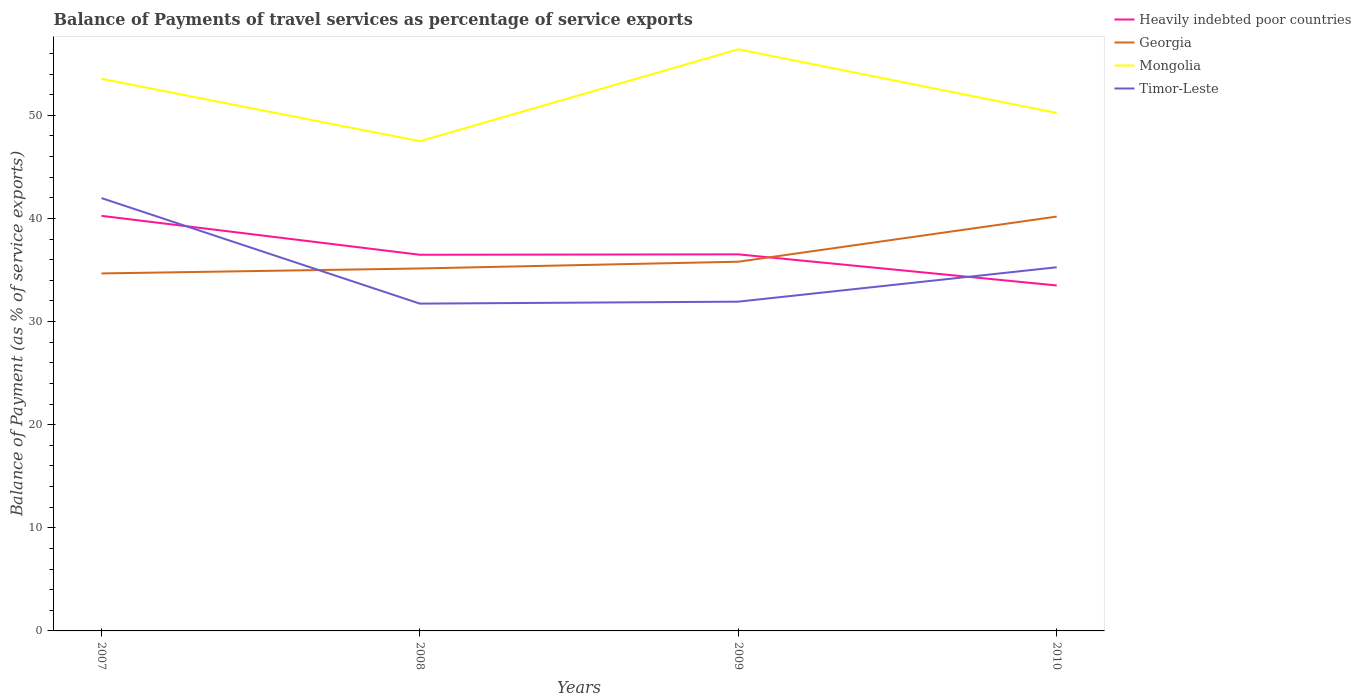How many different coloured lines are there?
Your answer should be very brief. 4. Across all years, what is the maximum balance of payments of travel services in Georgia?
Offer a terse response. 34.66. What is the total balance of payments of travel services in Timor-Leste in the graph?
Offer a terse response. -3.52. What is the difference between the highest and the second highest balance of payments of travel services in Timor-Leste?
Offer a terse response. 10.23. Is the balance of payments of travel services in Timor-Leste strictly greater than the balance of payments of travel services in Mongolia over the years?
Give a very brief answer. Yes. What is the difference between two consecutive major ticks on the Y-axis?
Your answer should be very brief. 10. How are the legend labels stacked?
Provide a short and direct response. Vertical. What is the title of the graph?
Your answer should be compact. Balance of Payments of travel services as percentage of service exports. Does "Lithuania" appear as one of the legend labels in the graph?
Provide a succinct answer. No. What is the label or title of the Y-axis?
Provide a short and direct response. Balance of Payment (as % of service exports). What is the Balance of Payment (as % of service exports) in Heavily indebted poor countries in 2007?
Provide a succinct answer. 40.25. What is the Balance of Payment (as % of service exports) of Georgia in 2007?
Keep it short and to the point. 34.66. What is the Balance of Payment (as % of service exports) of Mongolia in 2007?
Keep it short and to the point. 53.54. What is the Balance of Payment (as % of service exports) of Timor-Leste in 2007?
Provide a short and direct response. 41.97. What is the Balance of Payment (as % of service exports) of Heavily indebted poor countries in 2008?
Provide a succinct answer. 36.48. What is the Balance of Payment (as % of service exports) of Georgia in 2008?
Your answer should be very brief. 35.15. What is the Balance of Payment (as % of service exports) of Mongolia in 2008?
Offer a very short reply. 47.49. What is the Balance of Payment (as % of service exports) of Timor-Leste in 2008?
Ensure brevity in your answer.  31.74. What is the Balance of Payment (as % of service exports) in Heavily indebted poor countries in 2009?
Give a very brief answer. 36.51. What is the Balance of Payment (as % of service exports) of Georgia in 2009?
Your response must be concise. 35.8. What is the Balance of Payment (as % of service exports) in Mongolia in 2009?
Ensure brevity in your answer.  56.4. What is the Balance of Payment (as % of service exports) of Timor-Leste in 2009?
Provide a short and direct response. 31.93. What is the Balance of Payment (as % of service exports) of Heavily indebted poor countries in 2010?
Ensure brevity in your answer.  33.5. What is the Balance of Payment (as % of service exports) in Georgia in 2010?
Provide a succinct answer. 40.18. What is the Balance of Payment (as % of service exports) of Mongolia in 2010?
Your answer should be compact. 50.23. What is the Balance of Payment (as % of service exports) in Timor-Leste in 2010?
Give a very brief answer. 35.26. Across all years, what is the maximum Balance of Payment (as % of service exports) in Heavily indebted poor countries?
Your answer should be compact. 40.25. Across all years, what is the maximum Balance of Payment (as % of service exports) in Georgia?
Keep it short and to the point. 40.18. Across all years, what is the maximum Balance of Payment (as % of service exports) in Mongolia?
Offer a terse response. 56.4. Across all years, what is the maximum Balance of Payment (as % of service exports) in Timor-Leste?
Give a very brief answer. 41.97. Across all years, what is the minimum Balance of Payment (as % of service exports) in Heavily indebted poor countries?
Your answer should be very brief. 33.5. Across all years, what is the minimum Balance of Payment (as % of service exports) of Georgia?
Offer a very short reply. 34.66. Across all years, what is the minimum Balance of Payment (as % of service exports) in Mongolia?
Your response must be concise. 47.49. Across all years, what is the minimum Balance of Payment (as % of service exports) of Timor-Leste?
Your answer should be very brief. 31.74. What is the total Balance of Payment (as % of service exports) of Heavily indebted poor countries in the graph?
Provide a short and direct response. 146.74. What is the total Balance of Payment (as % of service exports) in Georgia in the graph?
Give a very brief answer. 145.79. What is the total Balance of Payment (as % of service exports) of Mongolia in the graph?
Give a very brief answer. 207.65. What is the total Balance of Payment (as % of service exports) of Timor-Leste in the graph?
Make the answer very short. 140.9. What is the difference between the Balance of Payment (as % of service exports) of Heavily indebted poor countries in 2007 and that in 2008?
Your answer should be compact. 3.77. What is the difference between the Balance of Payment (as % of service exports) of Georgia in 2007 and that in 2008?
Keep it short and to the point. -0.48. What is the difference between the Balance of Payment (as % of service exports) in Mongolia in 2007 and that in 2008?
Keep it short and to the point. 6.05. What is the difference between the Balance of Payment (as % of service exports) of Timor-Leste in 2007 and that in 2008?
Make the answer very short. 10.23. What is the difference between the Balance of Payment (as % of service exports) of Heavily indebted poor countries in 2007 and that in 2009?
Your answer should be compact. 3.73. What is the difference between the Balance of Payment (as % of service exports) in Georgia in 2007 and that in 2009?
Offer a very short reply. -1.14. What is the difference between the Balance of Payment (as % of service exports) in Mongolia in 2007 and that in 2009?
Provide a short and direct response. -2.86. What is the difference between the Balance of Payment (as % of service exports) of Timor-Leste in 2007 and that in 2009?
Your answer should be very brief. 10.04. What is the difference between the Balance of Payment (as % of service exports) of Heavily indebted poor countries in 2007 and that in 2010?
Provide a short and direct response. 6.75. What is the difference between the Balance of Payment (as % of service exports) in Georgia in 2007 and that in 2010?
Provide a short and direct response. -5.51. What is the difference between the Balance of Payment (as % of service exports) of Mongolia in 2007 and that in 2010?
Your response must be concise. 3.31. What is the difference between the Balance of Payment (as % of service exports) in Timor-Leste in 2007 and that in 2010?
Your answer should be very brief. 6.71. What is the difference between the Balance of Payment (as % of service exports) in Heavily indebted poor countries in 2008 and that in 2009?
Make the answer very short. -0.04. What is the difference between the Balance of Payment (as % of service exports) in Georgia in 2008 and that in 2009?
Offer a terse response. -0.65. What is the difference between the Balance of Payment (as % of service exports) of Mongolia in 2008 and that in 2009?
Ensure brevity in your answer.  -8.91. What is the difference between the Balance of Payment (as % of service exports) of Timor-Leste in 2008 and that in 2009?
Provide a succinct answer. -0.19. What is the difference between the Balance of Payment (as % of service exports) of Heavily indebted poor countries in 2008 and that in 2010?
Your answer should be very brief. 2.98. What is the difference between the Balance of Payment (as % of service exports) of Georgia in 2008 and that in 2010?
Offer a very short reply. -5.03. What is the difference between the Balance of Payment (as % of service exports) in Mongolia in 2008 and that in 2010?
Keep it short and to the point. -2.74. What is the difference between the Balance of Payment (as % of service exports) in Timor-Leste in 2008 and that in 2010?
Offer a terse response. -3.52. What is the difference between the Balance of Payment (as % of service exports) in Heavily indebted poor countries in 2009 and that in 2010?
Provide a succinct answer. 3.01. What is the difference between the Balance of Payment (as % of service exports) in Georgia in 2009 and that in 2010?
Your answer should be compact. -4.38. What is the difference between the Balance of Payment (as % of service exports) in Mongolia in 2009 and that in 2010?
Make the answer very short. 6.17. What is the difference between the Balance of Payment (as % of service exports) in Timor-Leste in 2009 and that in 2010?
Your response must be concise. -3.33. What is the difference between the Balance of Payment (as % of service exports) in Heavily indebted poor countries in 2007 and the Balance of Payment (as % of service exports) in Georgia in 2008?
Keep it short and to the point. 5.1. What is the difference between the Balance of Payment (as % of service exports) of Heavily indebted poor countries in 2007 and the Balance of Payment (as % of service exports) of Mongolia in 2008?
Your answer should be very brief. -7.24. What is the difference between the Balance of Payment (as % of service exports) of Heavily indebted poor countries in 2007 and the Balance of Payment (as % of service exports) of Timor-Leste in 2008?
Make the answer very short. 8.51. What is the difference between the Balance of Payment (as % of service exports) in Georgia in 2007 and the Balance of Payment (as % of service exports) in Mongolia in 2008?
Your answer should be very brief. -12.82. What is the difference between the Balance of Payment (as % of service exports) in Georgia in 2007 and the Balance of Payment (as % of service exports) in Timor-Leste in 2008?
Give a very brief answer. 2.93. What is the difference between the Balance of Payment (as % of service exports) in Mongolia in 2007 and the Balance of Payment (as % of service exports) in Timor-Leste in 2008?
Offer a very short reply. 21.8. What is the difference between the Balance of Payment (as % of service exports) of Heavily indebted poor countries in 2007 and the Balance of Payment (as % of service exports) of Georgia in 2009?
Provide a succinct answer. 4.45. What is the difference between the Balance of Payment (as % of service exports) in Heavily indebted poor countries in 2007 and the Balance of Payment (as % of service exports) in Mongolia in 2009?
Your answer should be very brief. -16.15. What is the difference between the Balance of Payment (as % of service exports) in Heavily indebted poor countries in 2007 and the Balance of Payment (as % of service exports) in Timor-Leste in 2009?
Ensure brevity in your answer.  8.32. What is the difference between the Balance of Payment (as % of service exports) in Georgia in 2007 and the Balance of Payment (as % of service exports) in Mongolia in 2009?
Offer a very short reply. -21.73. What is the difference between the Balance of Payment (as % of service exports) in Georgia in 2007 and the Balance of Payment (as % of service exports) in Timor-Leste in 2009?
Your answer should be compact. 2.74. What is the difference between the Balance of Payment (as % of service exports) of Mongolia in 2007 and the Balance of Payment (as % of service exports) of Timor-Leste in 2009?
Offer a terse response. 21.61. What is the difference between the Balance of Payment (as % of service exports) in Heavily indebted poor countries in 2007 and the Balance of Payment (as % of service exports) in Georgia in 2010?
Offer a terse response. 0.07. What is the difference between the Balance of Payment (as % of service exports) in Heavily indebted poor countries in 2007 and the Balance of Payment (as % of service exports) in Mongolia in 2010?
Give a very brief answer. -9.98. What is the difference between the Balance of Payment (as % of service exports) in Heavily indebted poor countries in 2007 and the Balance of Payment (as % of service exports) in Timor-Leste in 2010?
Keep it short and to the point. 4.99. What is the difference between the Balance of Payment (as % of service exports) in Georgia in 2007 and the Balance of Payment (as % of service exports) in Mongolia in 2010?
Your answer should be very brief. -15.56. What is the difference between the Balance of Payment (as % of service exports) of Georgia in 2007 and the Balance of Payment (as % of service exports) of Timor-Leste in 2010?
Keep it short and to the point. -0.6. What is the difference between the Balance of Payment (as % of service exports) in Mongolia in 2007 and the Balance of Payment (as % of service exports) in Timor-Leste in 2010?
Provide a short and direct response. 18.28. What is the difference between the Balance of Payment (as % of service exports) of Heavily indebted poor countries in 2008 and the Balance of Payment (as % of service exports) of Georgia in 2009?
Your response must be concise. 0.68. What is the difference between the Balance of Payment (as % of service exports) of Heavily indebted poor countries in 2008 and the Balance of Payment (as % of service exports) of Mongolia in 2009?
Offer a very short reply. -19.92. What is the difference between the Balance of Payment (as % of service exports) in Heavily indebted poor countries in 2008 and the Balance of Payment (as % of service exports) in Timor-Leste in 2009?
Give a very brief answer. 4.55. What is the difference between the Balance of Payment (as % of service exports) of Georgia in 2008 and the Balance of Payment (as % of service exports) of Mongolia in 2009?
Your answer should be very brief. -21.25. What is the difference between the Balance of Payment (as % of service exports) of Georgia in 2008 and the Balance of Payment (as % of service exports) of Timor-Leste in 2009?
Provide a short and direct response. 3.22. What is the difference between the Balance of Payment (as % of service exports) of Mongolia in 2008 and the Balance of Payment (as % of service exports) of Timor-Leste in 2009?
Give a very brief answer. 15.56. What is the difference between the Balance of Payment (as % of service exports) of Heavily indebted poor countries in 2008 and the Balance of Payment (as % of service exports) of Georgia in 2010?
Offer a very short reply. -3.7. What is the difference between the Balance of Payment (as % of service exports) in Heavily indebted poor countries in 2008 and the Balance of Payment (as % of service exports) in Mongolia in 2010?
Your answer should be very brief. -13.75. What is the difference between the Balance of Payment (as % of service exports) of Heavily indebted poor countries in 2008 and the Balance of Payment (as % of service exports) of Timor-Leste in 2010?
Keep it short and to the point. 1.21. What is the difference between the Balance of Payment (as % of service exports) of Georgia in 2008 and the Balance of Payment (as % of service exports) of Mongolia in 2010?
Your answer should be compact. -15.08. What is the difference between the Balance of Payment (as % of service exports) in Georgia in 2008 and the Balance of Payment (as % of service exports) in Timor-Leste in 2010?
Your response must be concise. -0.12. What is the difference between the Balance of Payment (as % of service exports) of Mongolia in 2008 and the Balance of Payment (as % of service exports) of Timor-Leste in 2010?
Give a very brief answer. 12.23. What is the difference between the Balance of Payment (as % of service exports) of Heavily indebted poor countries in 2009 and the Balance of Payment (as % of service exports) of Georgia in 2010?
Your answer should be compact. -3.66. What is the difference between the Balance of Payment (as % of service exports) of Heavily indebted poor countries in 2009 and the Balance of Payment (as % of service exports) of Mongolia in 2010?
Offer a terse response. -13.71. What is the difference between the Balance of Payment (as % of service exports) in Heavily indebted poor countries in 2009 and the Balance of Payment (as % of service exports) in Timor-Leste in 2010?
Give a very brief answer. 1.25. What is the difference between the Balance of Payment (as % of service exports) in Georgia in 2009 and the Balance of Payment (as % of service exports) in Mongolia in 2010?
Your answer should be compact. -14.43. What is the difference between the Balance of Payment (as % of service exports) of Georgia in 2009 and the Balance of Payment (as % of service exports) of Timor-Leste in 2010?
Offer a very short reply. 0.54. What is the difference between the Balance of Payment (as % of service exports) in Mongolia in 2009 and the Balance of Payment (as % of service exports) in Timor-Leste in 2010?
Provide a succinct answer. 21.14. What is the average Balance of Payment (as % of service exports) in Heavily indebted poor countries per year?
Your answer should be very brief. 36.68. What is the average Balance of Payment (as % of service exports) in Georgia per year?
Your answer should be compact. 36.45. What is the average Balance of Payment (as % of service exports) of Mongolia per year?
Provide a succinct answer. 51.91. What is the average Balance of Payment (as % of service exports) of Timor-Leste per year?
Offer a very short reply. 35.22. In the year 2007, what is the difference between the Balance of Payment (as % of service exports) of Heavily indebted poor countries and Balance of Payment (as % of service exports) of Georgia?
Make the answer very short. 5.59. In the year 2007, what is the difference between the Balance of Payment (as % of service exports) in Heavily indebted poor countries and Balance of Payment (as % of service exports) in Mongolia?
Ensure brevity in your answer.  -13.29. In the year 2007, what is the difference between the Balance of Payment (as % of service exports) of Heavily indebted poor countries and Balance of Payment (as % of service exports) of Timor-Leste?
Provide a short and direct response. -1.72. In the year 2007, what is the difference between the Balance of Payment (as % of service exports) of Georgia and Balance of Payment (as % of service exports) of Mongolia?
Give a very brief answer. -18.87. In the year 2007, what is the difference between the Balance of Payment (as % of service exports) in Georgia and Balance of Payment (as % of service exports) in Timor-Leste?
Give a very brief answer. -7.31. In the year 2007, what is the difference between the Balance of Payment (as % of service exports) of Mongolia and Balance of Payment (as % of service exports) of Timor-Leste?
Offer a very short reply. 11.57. In the year 2008, what is the difference between the Balance of Payment (as % of service exports) in Heavily indebted poor countries and Balance of Payment (as % of service exports) in Georgia?
Your answer should be very brief. 1.33. In the year 2008, what is the difference between the Balance of Payment (as % of service exports) of Heavily indebted poor countries and Balance of Payment (as % of service exports) of Mongolia?
Your response must be concise. -11.01. In the year 2008, what is the difference between the Balance of Payment (as % of service exports) in Heavily indebted poor countries and Balance of Payment (as % of service exports) in Timor-Leste?
Your answer should be compact. 4.74. In the year 2008, what is the difference between the Balance of Payment (as % of service exports) of Georgia and Balance of Payment (as % of service exports) of Mongolia?
Your answer should be very brief. -12.34. In the year 2008, what is the difference between the Balance of Payment (as % of service exports) in Georgia and Balance of Payment (as % of service exports) in Timor-Leste?
Your answer should be compact. 3.41. In the year 2008, what is the difference between the Balance of Payment (as % of service exports) in Mongolia and Balance of Payment (as % of service exports) in Timor-Leste?
Your response must be concise. 15.75. In the year 2009, what is the difference between the Balance of Payment (as % of service exports) in Heavily indebted poor countries and Balance of Payment (as % of service exports) in Georgia?
Keep it short and to the point. 0.71. In the year 2009, what is the difference between the Balance of Payment (as % of service exports) in Heavily indebted poor countries and Balance of Payment (as % of service exports) in Mongolia?
Make the answer very short. -19.88. In the year 2009, what is the difference between the Balance of Payment (as % of service exports) in Heavily indebted poor countries and Balance of Payment (as % of service exports) in Timor-Leste?
Offer a terse response. 4.59. In the year 2009, what is the difference between the Balance of Payment (as % of service exports) in Georgia and Balance of Payment (as % of service exports) in Mongolia?
Ensure brevity in your answer.  -20.6. In the year 2009, what is the difference between the Balance of Payment (as % of service exports) of Georgia and Balance of Payment (as % of service exports) of Timor-Leste?
Your answer should be very brief. 3.87. In the year 2009, what is the difference between the Balance of Payment (as % of service exports) of Mongolia and Balance of Payment (as % of service exports) of Timor-Leste?
Your answer should be compact. 24.47. In the year 2010, what is the difference between the Balance of Payment (as % of service exports) of Heavily indebted poor countries and Balance of Payment (as % of service exports) of Georgia?
Make the answer very short. -6.68. In the year 2010, what is the difference between the Balance of Payment (as % of service exports) in Heavily indebted poor countries and Balance of Payment (as % of service exports) in Mongolia?
Offer a terse response. -16.73. In the year 2010, what is the difference between the Balance of Payment (as % of service exports) of Heavily indebted poor countries and Balance of Payment (as % of service exports) of Timor-Leste?
Make the answer very short. -1.76. In the year 2010, what is the difference between the Balance of Payment (as % of service exports) in Georgia and Balance of Payment (as % of service exports) in Mongolia?
Provide a short and direct response. -10.05. In the year 2010, what is the difference between the Balance of Payment (as % of service exports) of Georgia and Balance of Payment (as % of service exports) of Timor-Leste?
Provide a short and direct response. 4.92. In the year 2010, what is the difference between the Balance of Payment (as % of service exports) of Mongolia and Balance of Payment (as % of service exports) of Timor-Leste?
Provide a short and direct response. 14.97. What is the ratio of the Balance of Payment (as % of service exports) of Heavily indebted poor countries in 2007 to that in 2008?
Make the answer very short. 1.1. What is the ratio of the Balance of Payment (as % of service exports) in Georgia in 2007 to that in 2008?
Give a very brief answer. 0.99. What is the ratio of the Balance of Payment (as % of service exports) of Mongolia in 2007 to that in 2008?
Provide a short and direct response. 1.13. What is the ratio of the Balance of Payment (as % of service exports) of Timor-Leste in 2007 to that in 2008?
Your answer should be compact. 1.32. What is the ratio of the Balance of Payment (as % of service exports) of Heavily indebted poor countries in 2007 to that in 2009?
Provide a short and direct response. 1.1. What is the ratio of the Balance of Payment (as % of service exports) in Georgia in 2007 to that in 2009?
Offer a terse response. 0.97. What is the ratio of the Balance of Payment (as % of service exports) in Mongolia in 2007 to that in 2009?
Your answer should be very brief. 0.95. What is the ratio of the Balance of Payment (as % of service exports) in Timor-Leste in 2007 to that in 2009?
Ensure brevity in your answer.  1.31. What is the ratio of the Balance of Payment (as % of service exports) in Heavily indebted poor countries in 2007 to that in 2010?
Your response must be concise. 1.2. What is the ratio of the Balance of Payment (as % of service exports) in Georgia in 2007 to that in 2010?
Your answer should be very brief. 0.86. What is the ratio of the Balance of Payment (as % of service exports) of Mongolia in 2007 to that in 2010?
Your answer should be compact. 1.07. What is the ratio of the Balance of Payment (as % of service exports) in Timor-Leste in 2007 to that in 2010?
Keep it short and to the point. 1.19. What is the ratio of the Balance of Payment (as % of service exports) in Georgia in 2008 to that in 2009?
Offer a terse response. 0.98. What is the ratio of the Balance of Payment (as % of service exports) of Mongolia in 2008 to that in 2009?
Provide a succinct answer. 0.84. What is the ratio of the Balance of Payment (as % of service exports) in Timor-Leste in 2008 to that in 2009?
Provide a succinct answer. 0.99. What is the ratio of the Balance of Payment (as % of service exports) of Heavily indebted poor countries in 2008 to that in 2010?
Offer a terse response. 1.09. What is the ratio of the Balance of Payment (as % of service exports) in Georgia in 2008 to that in 2010?
Provide a short and direct response. 0.87. What is the ratio of the Balance of Payment (as % of service exports) of Mongolia in 2008 to that in 2010?
Ensure brevity in your answer.  0.95. What is the ratio of the Balance of Payment (as % of service exports) in Timor-Leste in 2008 to that in 2010?
Your answer should be very brief. 0.9. What is the ratio of the Balance of Payment (as % of service exports) of Heavily indebted poor countries in 2009 to that in 2010?
Offer a very short reply. 1.09. What is the ratio of the Balance of Payment (as % of service exports) of Georgia in 2009 to that in 2010?
Give a very brief answer. 0.89. What is the ratio of the Balance of Payment (as % of service exports) in Mongolia in 2009 to that in 2010?
Provide a succinct answer. 1.12. What is the ratio of the Balance of Payment (as % of service exports) of Timor-Leste in 2009 to that in 2010?
Make the answer very short. 0.91. What is the difference between the highest and the second highest Balance of Payment (as % of service exports) in Heavily indebted poor countries?
Provide a short and direct response. 3.73. What is the difference between the highest and the second highest Balance of Payment (as % of service exports) of Georgia?
Provide a succinct answer. 4.38. What is the difference between the highest and the second highest Balance of Payment (as % of service exports) of Mongolia?
Give a very brief answer. 2.86. What is the difference between the highest and the second highest Balance of Payment (as % of service exports) of Timor-Leste?
Make the answer very short. 6.71. What is the difference between the highest and the lowest Balance of Payment (as % of service exports) of Heavily indebted poor countries?
Keep it short and to the point. 6.75. What is the difference between the highest and the lowest Balance of Payment (as % of service exports) in Georgia?
Provide a succinct answer. 5.51. What is the difference between the highest and the lowest Balance of Payment (as % of service exports) in Mongolia?
Ensure brevity in your answer.  8.91. What is the difference between the highest and the lowest Balance of Payment (as % of service exports) in Timor-Leste?
Your response must be concise. 10.23. 